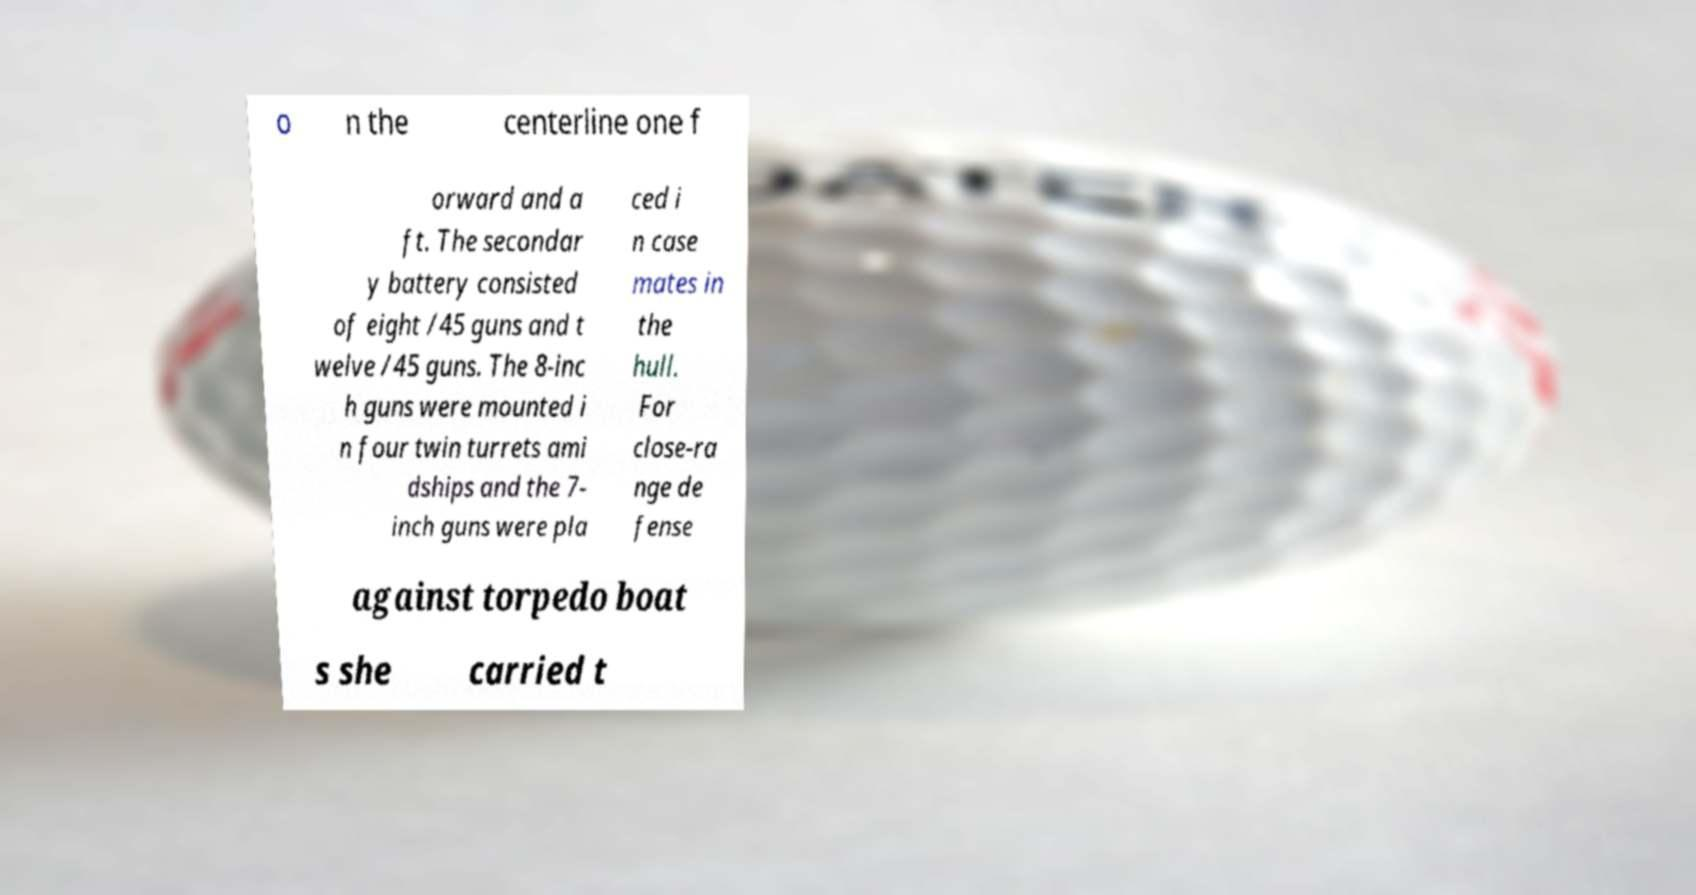Please identify and transcribe the text found in this image. o n the centerline one f orward and a ft. The secondar y battery consisted of eight /45 guns and t welve /45 guns. The 8-inc h guns were mounted i n four twin turrets ami dships and the 7- inch guns were pla ced i n case mates in the hull. For close-ra nge de fense against torpedo boat s she carried t 